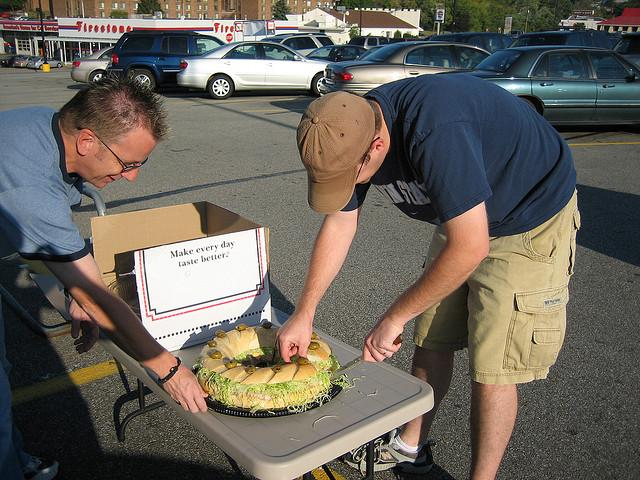How many days ago was this cake made? one 